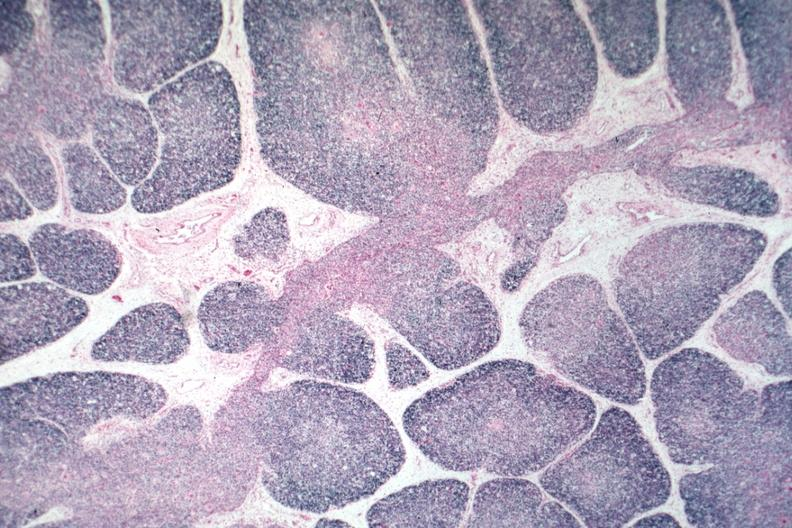s endocrine present?
Answer the question using a single word or phrase. No 